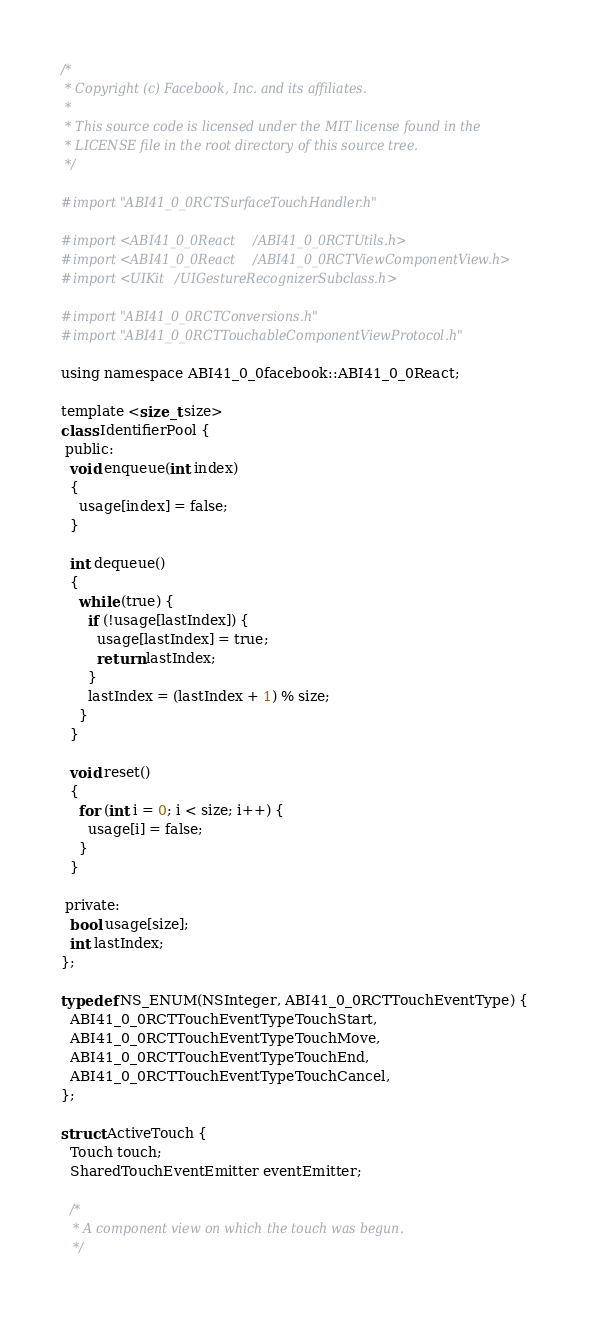Convert code to text. <code><loc_0><loc_0><loc_500><loc_500><_ObjectiveC_>/*
 * Copyright (c) Facebook, Inc. and its affiliates.
 *
 * This source code is licensed under the MIT license found in the
 * LICENSE file in the root directory of this source tree.
 */

#import "ABI41_0_0RCTSurfaceTouchHandler.h"

#import <ABI41_0_0React/ABI41_0_0RCTUtils.h>
#import <ABI41_0_0React/ABI41_0_0RCTViewComponentView.h>
#import <UIKit/UIGestureRecognizerSubclass.h>

#import "ABI41_0_0RCTConversions.h"
#import "ABI41_0_0RCTTouchableComponentViewProtocol.h"

using namespace ABI41_0_0facebook::ABI41_0_0React;

template <size_t size>
class IdentifierPool {
 public:
  void enqueue(int index)
  {
    usage[index] = false;
  }

  int dequeue()
  {
    while (true) {
      if (!usage[lastIndex]) {
        usage[lastIndex] = true;
        return lastIndex;
      }
      lastIndex = (lastIndex + 1) % size;
    }
  }

  void reset()
  {
    for (int i = 0; i < size; i++) {
      usage[i] = false;
    }
  }

 private:
  bool usage[size];
  int lastIndex;
};

typedef NS_ENUM(NSInteger, ABI41_0_0RCTTouchEventType) {
  ABI41_0_0RCTTouchEventTypeTouchStart,
  ABI41_0_0RCTTouchEventTypeTouchMove,
  ABI41_0_0RCTTouchEventTypeTouchEnd,
  ABI41_0_0RCTTouchEventTypeTouchCancel,
};

struct ActiveTouch {
  Touch touch;
  SharedTouchEventEmitter eventEmitter;

  /*
   * A component view on which the touch was begun.
   */</code> 